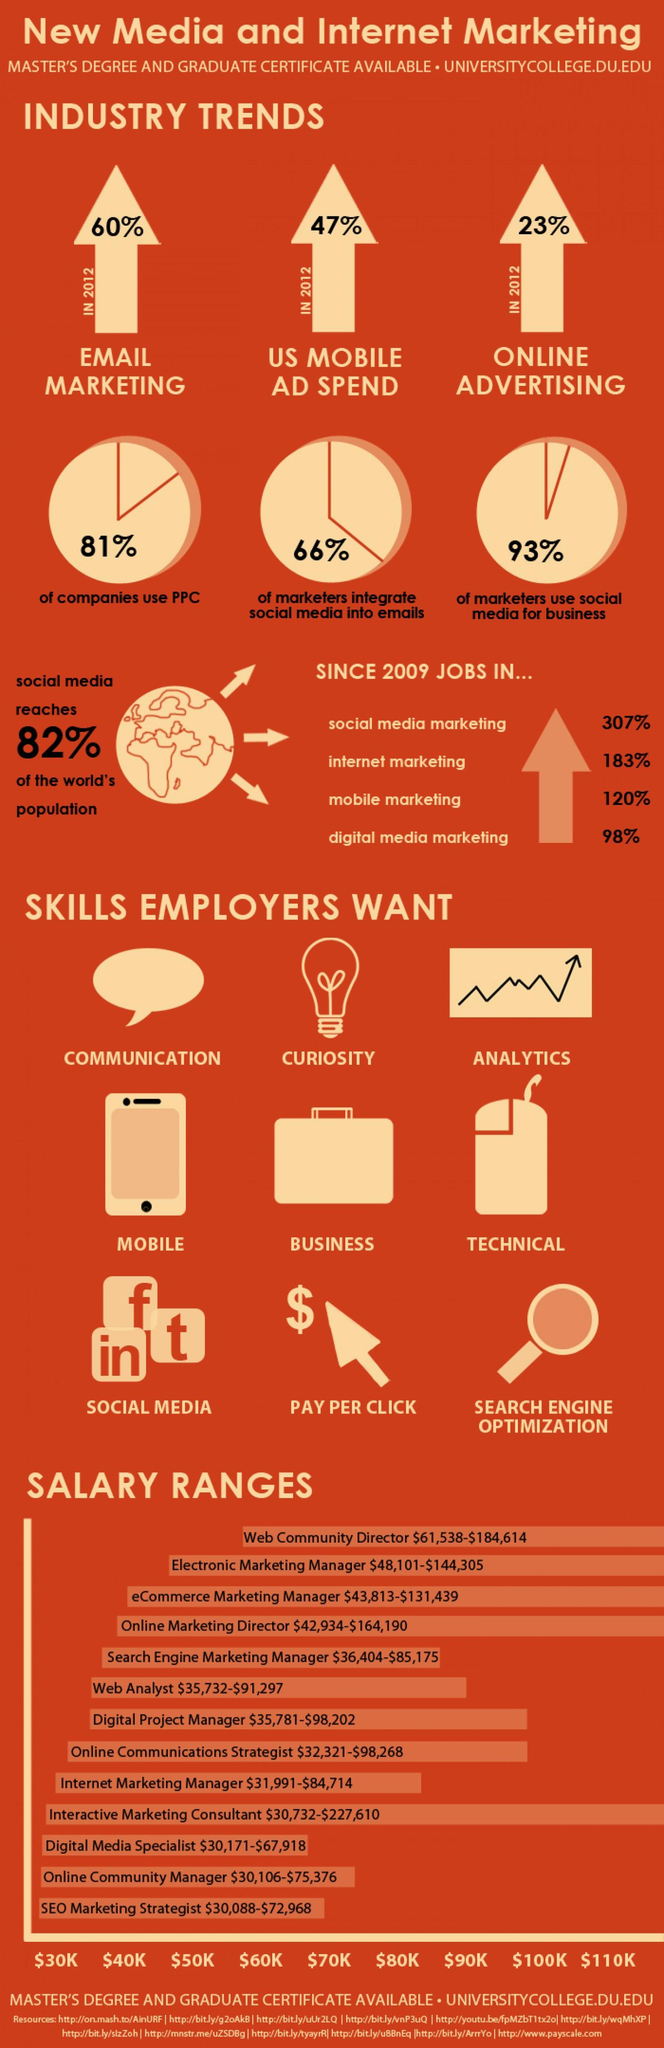Specify some key components in this picture. The job profile of Web Community Director in the United States has the highest salary range. The SEO Marketing Strategist job profile has the lowest salary range in the United States. In 2012, the United States spent 23% of its money on online advertising. Between 2009 and the present day, the number of jobs in internet marketing in the United States has increased by 183%. In 2012, the United States spent 47% of its total advertising budget on mobile advertising. 